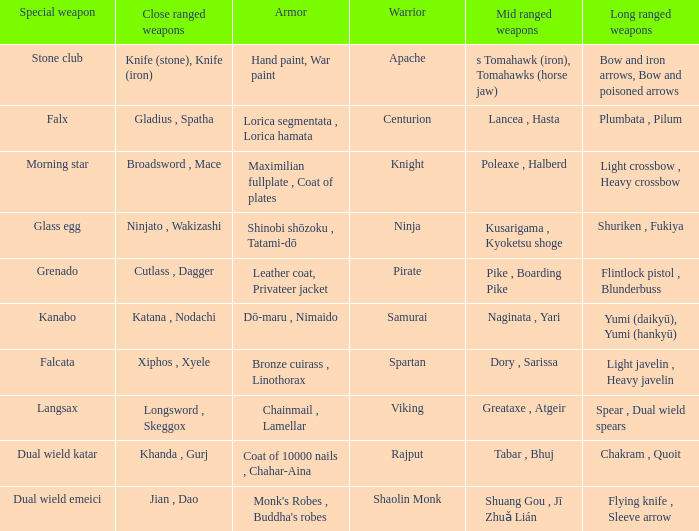If the special weapon is the Grenado, what is the armor? Leather coat, Privateer jacket. 